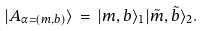Convert formula to latex. <formula><loc_0><loc_0><loc_500><loc_500>| A _ { \alpha = ( m , b ) } \rangle \, = \, | m , b \rangle _ { 1 } | \tilde { m } , \tilde { b } \rangle _ { 2 } .</formula> 